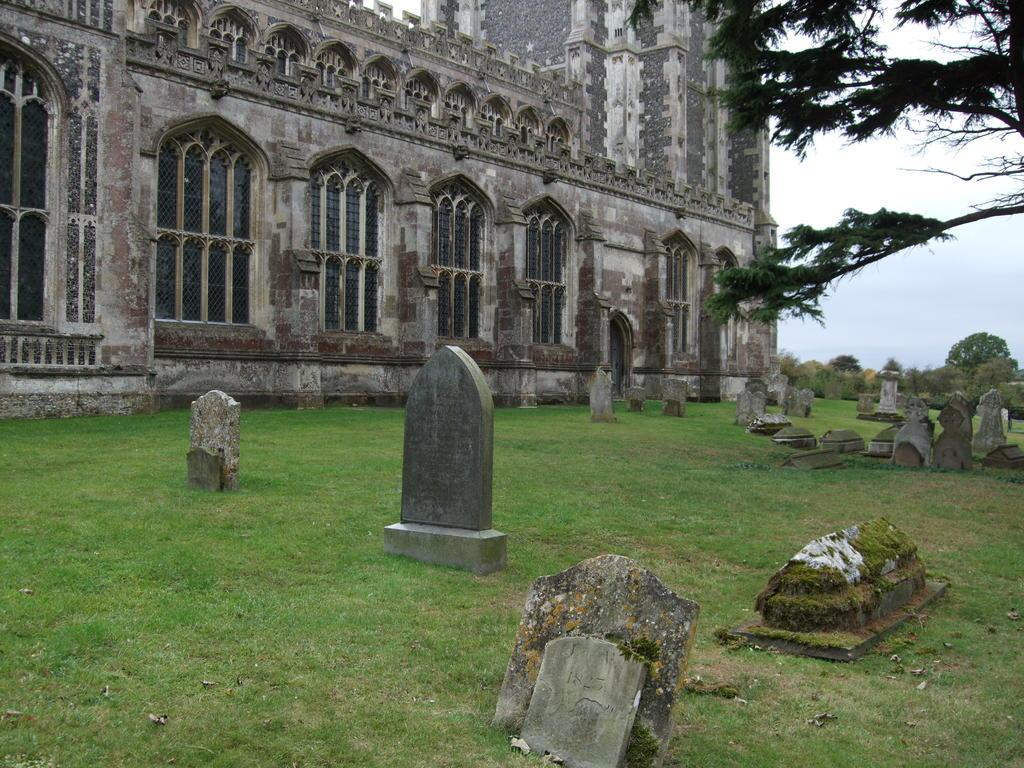What type of structure is visible in the image? There is a building in the image. What is located in front of the building? There is a graveyard in front of the building. What can be seen on the right side of the image? There is a tree on the right side of the image. What is visible in the background of the image? The sky is visible in the background of the image. What type of furniture is present in the image? There is no furniture present in the image. How does the credit affect the appearance of the building in the image? There is no mention of credit in the image, so it does not affect the appearance of the building. 